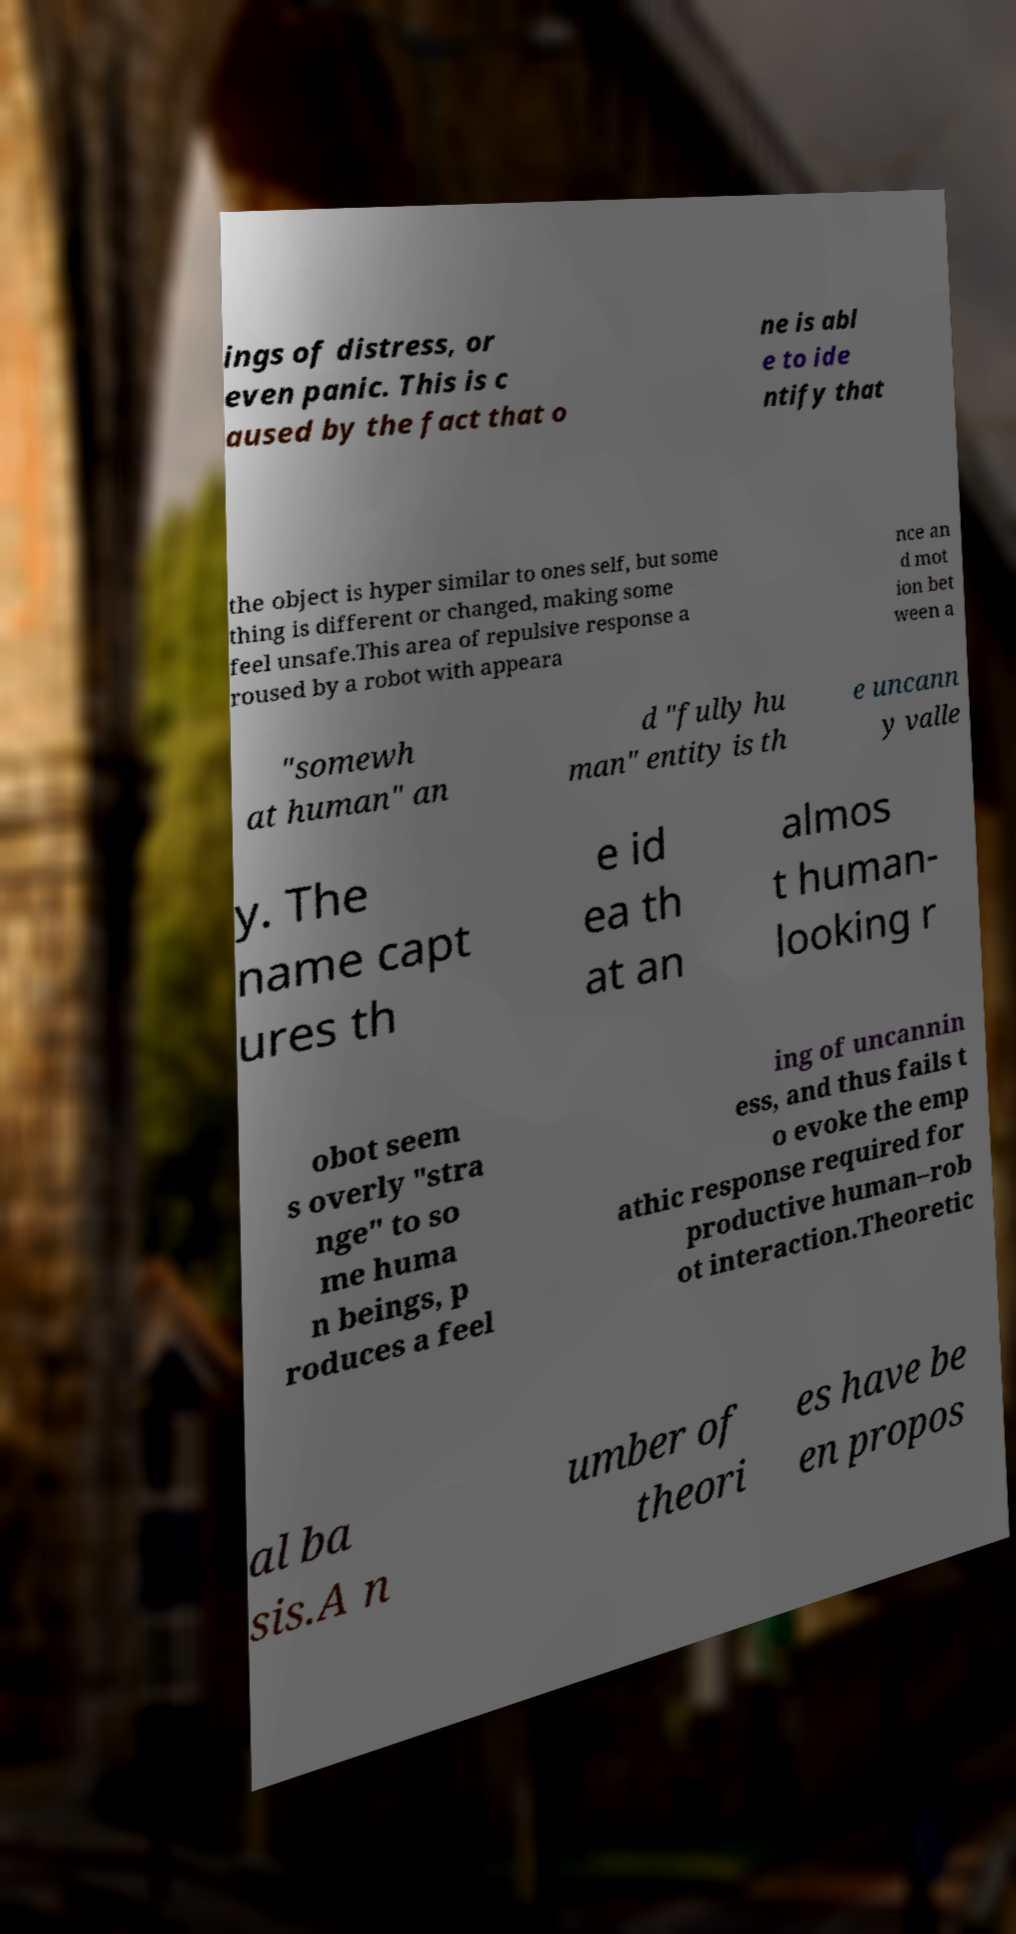I need the written content from this picture converted into text. Can you do that? ings of distress, or even panic. This is c aused by the fact that o ne is abl e to ide ntify that the object is hyper similar to ones self, but some thing is different or changed, making some feel unsafe.This area of repulsive response a roused by a robot with appeara nce an d mot ion bet ween a "somewh at human" an d "fully hu man" entity is th e uncann y valle y. The name capt ures th e id ea th at an almos t human- looking r obot seem s overly "stra nge" to so me huma n beings, p roduces a feel ing of uncannin ess, and thus fails t o evoke the emp athic response required for productive human–rob ot interaction.Theoretic al ba sis.A n umber of theori es have be en propos 